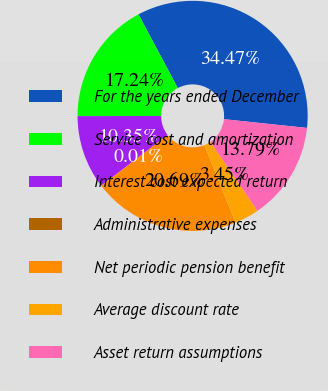<chart> <loc_0><loc_0><loc_500><loc_500><pie_chart><fcel>For the years ended December<fcel>Service cost and amortization<fcel>Interest cost expected return<fcel>Administrative expenses<fcel>Net periodic pension benefit<fcel>Average discount rate<fcel>Asset return assumptions<nl><fcel>34.47%<fcel>17.24%<fcel>10.35%<fcel>0.01%<fcel>20.69%<fcel>3.45%<fcel>13.79%<nl></chart> 